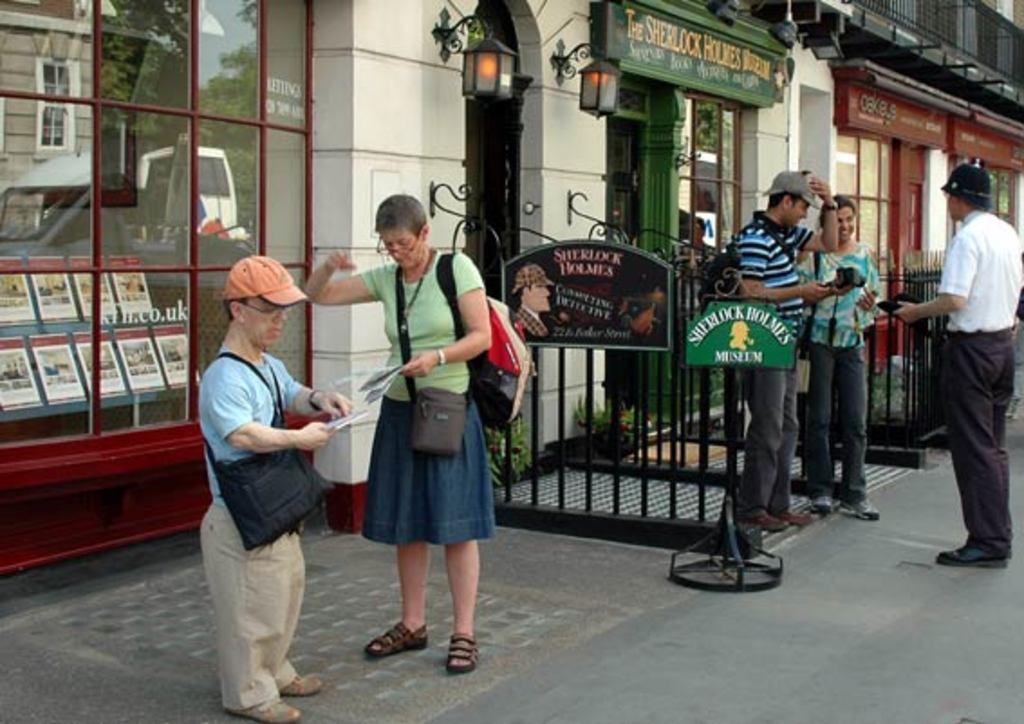Please provide a concise description of this image. In this image, we can see people standing and wearing bags, some of them are wearing caps. In the background, we can see buildings, lights, sign boards and name boards. At the bottom, there is road. 